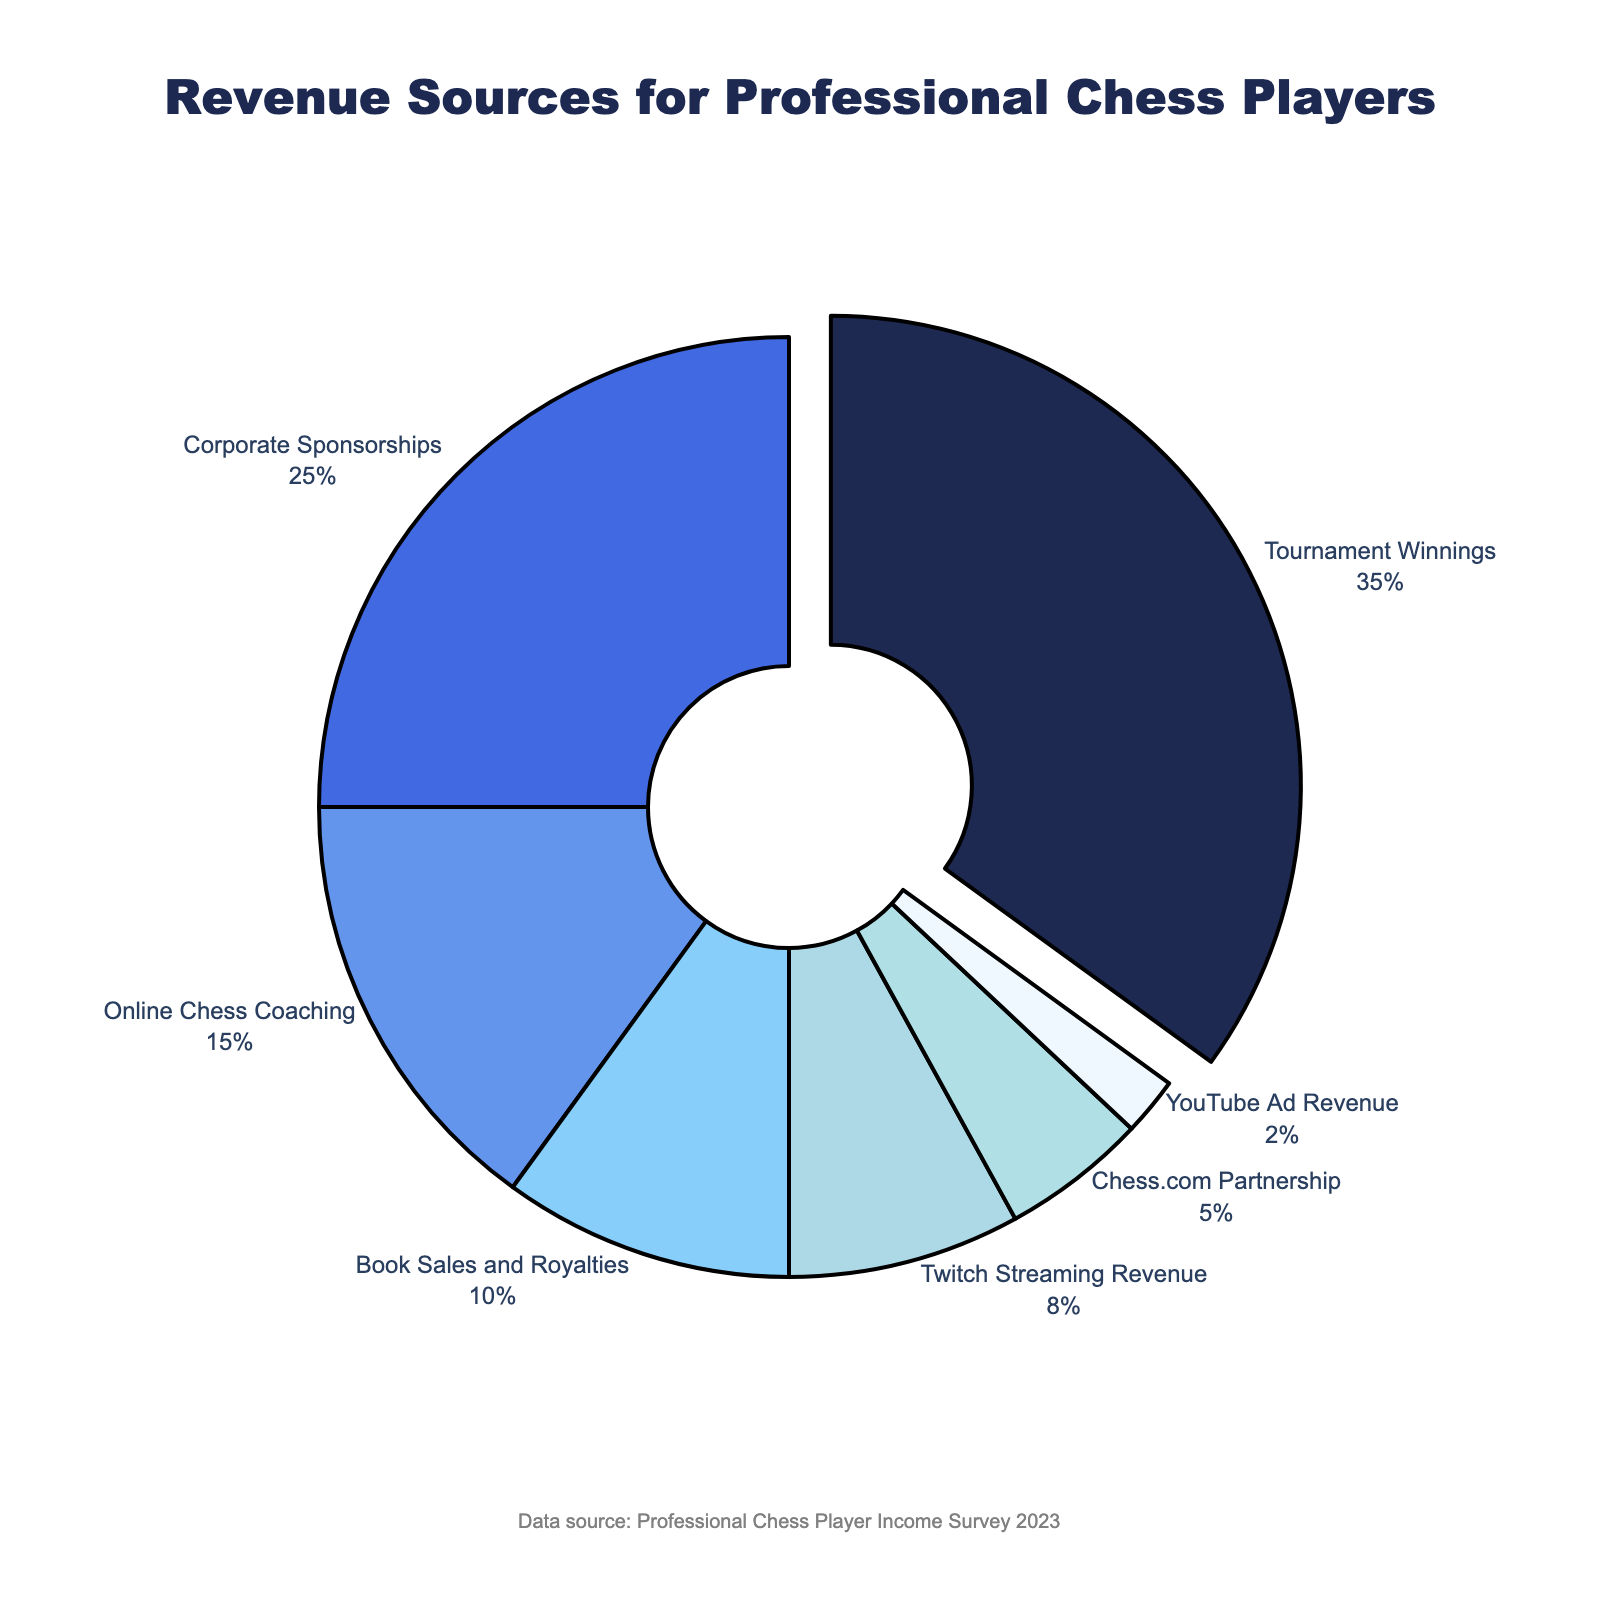What revenue source contributes the highest percentage? By looking at the pie chart, the segment with the largest area represents Tournament Winnings, which is highlighted and pulled out slightly from the pie. This indicates that Tournament Winnings has the highest percentage.
Answer: Tournament Winnings Which revenue source has the smallest contribution? The segment with the smallest area in the pie chart represents YouTube Ad Revenue.
Answer: YouTube Ad Revenue How much more is earned from Tournament Winnings compared to Twitch Streaming Revenue? Tournament Winnings contribute 35% and Twitch Streaming Revenue contributes 8%. The difference is 35% - 8% = 27%.
Answer: 27% What is the combined percentage of revenue from Online Chess Coaching and Book Sales and Royalties? Online Chess Coaching contributes 15% and Book Sales and Royalties contribute 10%. The combined percentage is 15% + 10% = 25%.
Answer: 25% Which revenue sources together make up exactly half (50%) of the total revenue? Adding up the percentages, Tournament Winnings (35%), and Corporate Sponsorships (25%) give a cumulative value of 35% + 25% = 60%, which is more than half. Tournament Winnings (35%) and Online Chess Coaching (15%) give 35% + 15% = 50%. So these two together make up half.
Answer: Tournament Winnings and Online Chess Coaching Which revenue sources have a lower contribution than Corporate Sponsorships? From the pie chart, the revenue sources with smaller segments than Corporate Sponsorships (25%) are Online Chess Coaching (15%), Book Sales and Royalties (10%), Twitch Streaming Revenue (8%), Chess.com Partnership (5%), and YouTube Ad Revenue (2%).
Answer: Online Chess Coaching, Book Sales and Royalties, Twitch Streaming Revenue, Chess.com Partnership, YouTube Ad Revenue What fraction of the total revenue comes from sources contributing less than 10% each? Adding up the percentages for Book Sales and Royalties (10%), Twitch Streaming Revenue (8%), Chess.com Partnership (5%), and YouTube Ad Revenue (2%), we get 10% + 8% + 5% + 2% = 25%.
Answer: 25% What is the visual attribute used to highlight a revenue source in the chart? The pie chart emphasizes Tournament Winnings by pulling its segment out slightly from the rest of the pie. This visual attribute indicates that it's the most significant source of revenue.
Answer: Pulling the segment out How does revenue from Corporate Sponsorships compare to the sum of Chess.com Partnership and YouTube Ad Revenue? Corporate Sponsorships contribute 25%, while Chess.com Partnership and YouTube Ad Revenue together contribute 5% + 2% = 7%. Thus, Corporate Sponsorships contribute a significantly higher percentage.
Answer: Corporate Sponsorships is greater What is the combined percentage of revenue sources other than Tournament Winnings? The total percentage of all sources is 100%. Excluding Tournament Winnings (35%), the combined percentage is 100% - 35% = 65%.
Answer: 65% 